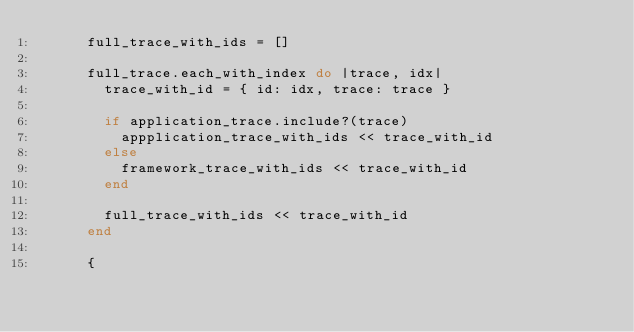<code> <loc_0><loc_0><loc_500><loc_500><_Ruby_>      full_trace_with_ids = []

      full_trace.each_with_index do |trace, idx|
        trace_with_id = { id: idx, trace: trace }

        if application_trace.include?(trace)
          appplication_trace_with_ids << trace_with_id
        else
          framework_trace_with_ids << trace_with_id
        end

        full_trace_with_ids << trace_with_id
      end

      {</code> 